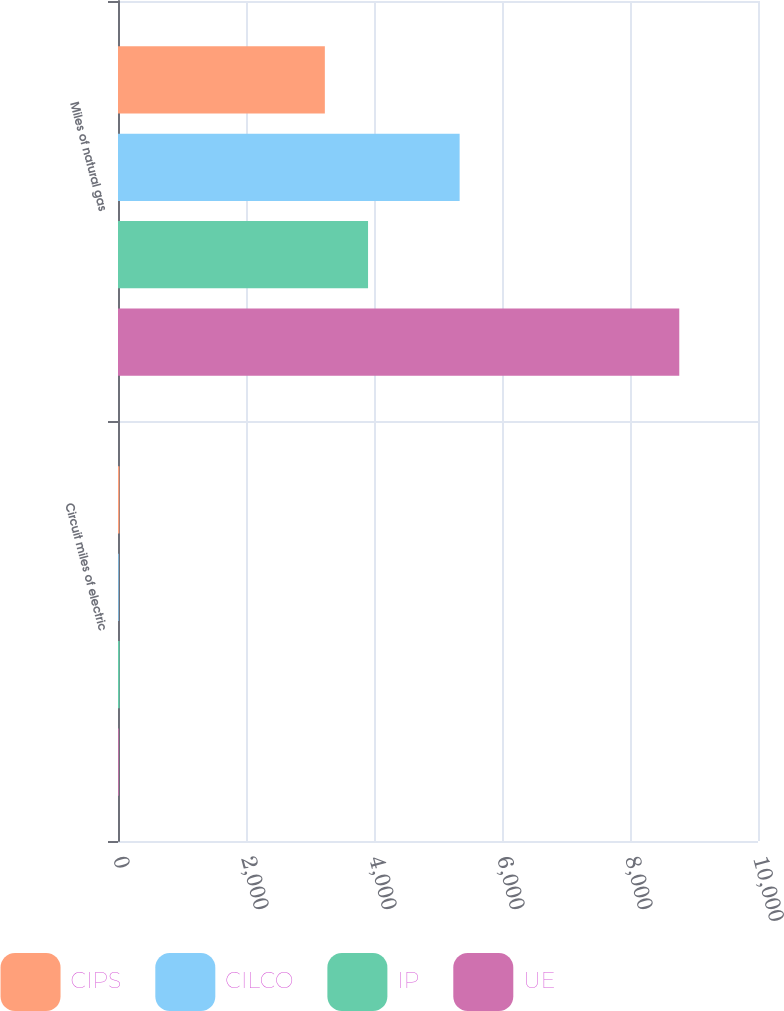Convert chart. <chart><loc_0><loc_0><loc_500><loc_500><stacked_bar_chart><ecel><fcel>Circuit miles of electric<fcel>Miles of natural gas<nl><fcel>CIPS<fcel>22<fcel>3232<nl><fcel>CILCO<fcel>11<fcel>5338<nl><fcel>IP<fcel>25<fcel>3907<nl><fcel>UE<fcel>12<fcel>8770<nl></chart> 